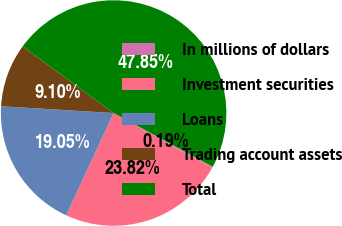Convert chart. <chart><loc_0><loc_0><loc_500><loc_500><pie_chart><fcel>In millions of dollars<fcel>Investment securities<fcel>Loans<fcel>Trading account assets<fcel>Total<nl><fcel>0.19%<fcel>23.82%<fcel>19.05%<fcel>9.1%<fcel>47.85%<nl></chart> 